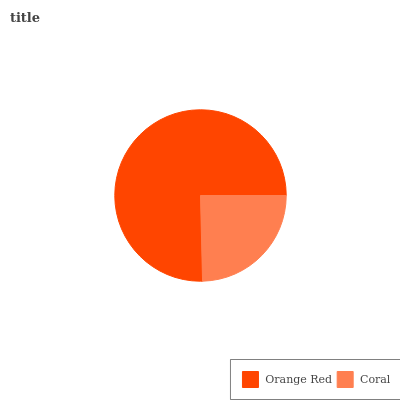Is Coral the minimum?
Answer yes or no. Yes. Is Orange Red the maximum?
Answer yes or no. Yes. Is Coral the maximum?
Answer yes or no. No. Is Orange Red greater than Coral?
Answer yes or no. Yes. Is Coral less than Orange Red?
Answer yes or no. Yes. Is Coral greater than Orange Red?
Answer yes or no. No. Is Orange Red less than Coral?
Answer yes or no. No. Is Orange Red the high median?
Answer yes or no. Yes. Is Coral the low median?
Answer yes or no. Yes. Is Coral the high median?
Answer yes or no. No. Is Orange Red the low median?
Answer yes or no. No. 